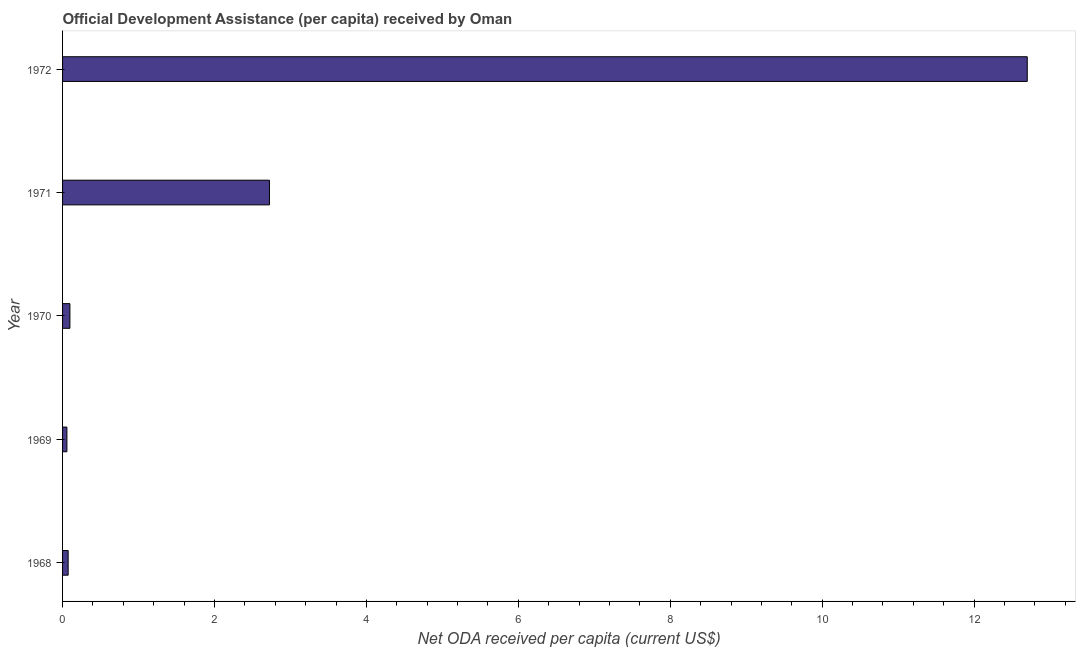Does the graph contain grids?
Your response must be concise. No. What is the title of the graph?
Your answer should be compact. Official Development Assistance (per capita) received by Oman. What is the label or title of the X-axis?
Your response must be concise. Net ODA received per capita (current US$). What is the label or title of the Y-axis?
Offer a very short reply. Year. What is the net oda received per capita in 1970?
Provide a short and direct response. 0.1. Across all years, what is the maximum net oda received per capita?
Make the answer very short. 12.7. Across all years, what is the minimum net oda received per capita?
Make the answer very short. 0.06. In which year was the net oda received per capita maximum?
Keep it short and to the point. 1972. In which year was the net oda received per capita minimum?
Offer a very short reply. 1969. What is the sum of the net oda received per capita?
Offer a terse response. 15.65. What is the difference between the net oda received per capita in 1969 and 1972?
Make the answer very short. -12.64. What is the average net oda received per capita per year?
Keep it short and to the point. 3.13. What is the median net oda received per capita?
Make the answer very short. 0.1. In how many years, is the net oda received per capita greater than 4.4 US$?
Keep it short and to the point. 1. What is the ratio of the net oda received per capita in 1968 to that in 1970?
Give a very brief answer. 0.76. Is the net oda received per capita in 1971 less than that in 1972?
Keep it short and to the point. Yes. Is the difference between the net oda received per capita in 1971 and 1972 greater than the difference between any two years?
Offer a terse response. No. What is the difference between the highest and the second highest net oda received per capita?
Make the answer very short. 9.98. What is the difference between the highest and the lowest net oda received per capita?
Provide a short and direct response. 12.64. In how many years, is the net oda received per capita greater than the average net oda received per capita taken over all years?
Offer a terse response. 1. How many bars are there?
Provide a short and direct response. 5. How many years are there in the graph?
Your answer should be very brief. 5. Are the values on the major ticks of X-axis written in scientific E-notation?
Your response must be concise. No. What is the Net ODA received per capita (current US$) of 1968?
Provide a short and direct response. 0.07. What is the Net ODA received per capita (current US$) in 1969?
Keep it short and to the point. 0.06. What is the Net ODA received per capita (current US$) of 1970?
Your answer should be compact. 0.1. What is the Net ODA received per capita (current US$) of 1971?
Provide a short and direct response. 2.72. What is the Net ODA received per capita (current US$) of 1972?
Ensure brevity in your answer.  12.7. What is the difference between the Net ODA received per capita (current US$) in 1968 and 1969?
Keep it short and to the point. 0.02. What is the difference between the Net ODA received per capita (current US$) in 1968 and 1970?
Make the answer very short. -0.02. What is the difference between the Net ODA received per capita (current US$) in 1968 and 1971?
Provide a succinct answer. -2.65. What is the difference between the Net ODA received per capita (current US$) in 1968 and 1972?
Your response must be concise. -12.63. What is the difference between the Net ODA received per capita (current US$) in 1969 and 1970?
Keep it short and to the point. -0.04. What is the difference between the Net ODA received per capita (current US$) in 1969 and 1971?
Offer a very short reply. -2.67. What is the difference between the Net ODA received per capita (current US$) in 1969 and 1972?
Your answer should be compact. -12.64. What is the difference between the Net ODA received per capita (current US$) in 1970 and 1971?
Keep it short and to the point. -2.63. What is the difference between the Net ODA received per capita (current US$) in 1970 and 1972?
Ensure brevity in your answer.  -12.6. What is the difference between the Net ODA received per capita (current US$) in 1971 and 1972?
Make the answer very short. -9.98. What is the ratio of the Net ODA received per capita (current US$) in 1968 to that in 1969?
Your response must be concise. 1.29. What is the ratio of the Net ODA received per capita (current US$) in 1968 to that in 1970?
Ensure brevity in your answer.  0.76. What is the ratio of the Net ODA received per capita (current US$) in 1968 to that in 1971?
Provide a short and direct response. 0.03. What is the ratio of the Net ODA received per capita (current US$) in 1968 to that in 1972?
Provide a short and direct response. 0.01. What is the ratio of the Net ODA received per capita (current US$) in 1969 to that in 1970?
Offer a terse response. 0.59. What is the ratio of the Net ODA received per capita (current US$) in 1969 to that in 1971?
Offer a very short reply. 0.02. What is the ratio of the Net ODA received per capita (current US$) in 1969 to that in 1972?
Keep it short and to the point. 0. What is the ratio of the Net ODA received per capita (current US$) in 1970 to that in 1971?
Provide a succinct answer. 0.04. What is the ratio of the Net ODA received per capita (current US$) in 1970 to that in 1972?
Ensure brevity in your answer.  0.01. What is the ratio of the Net ODA received per capita (current US$) in 1971 to that in 1972?
Make the answer very short. 0.21. 